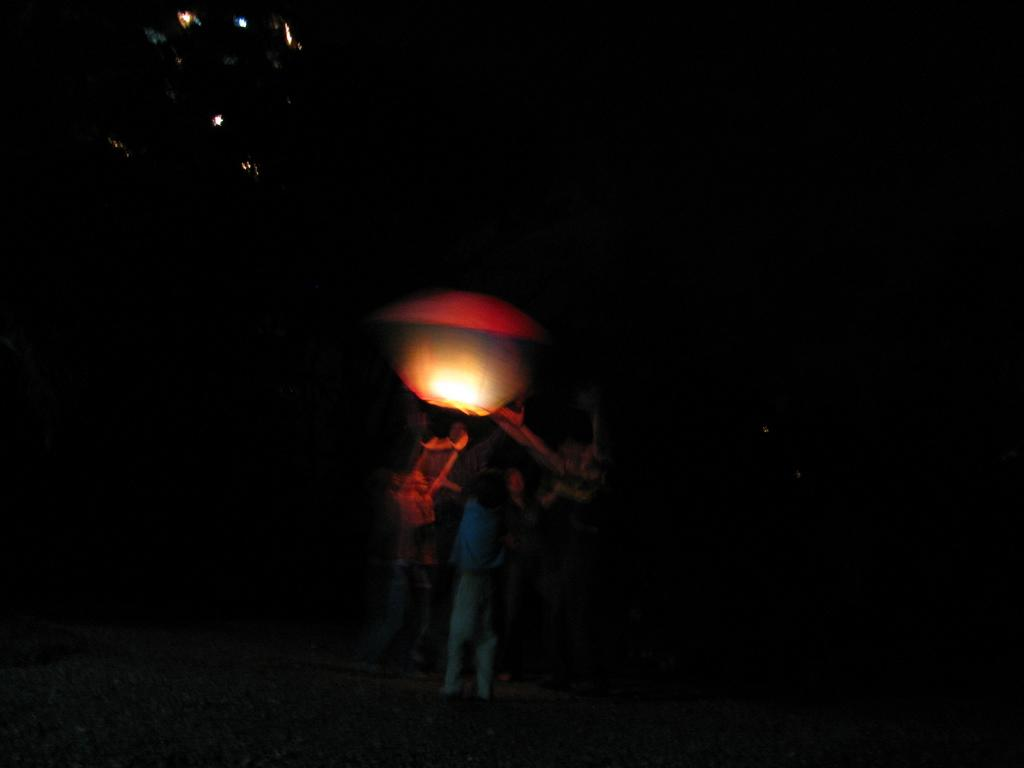Where was the image taken? The image was taken outdoors. What can be observed about the background of the image? The background of the image is dark. Who or what is the main subject in the image? There is a person in the middle of the image. Can you identify any light source in the image? Yes, there is a light in the image. What book is the person reading in the image? There is no book or reading activity present in the image. 